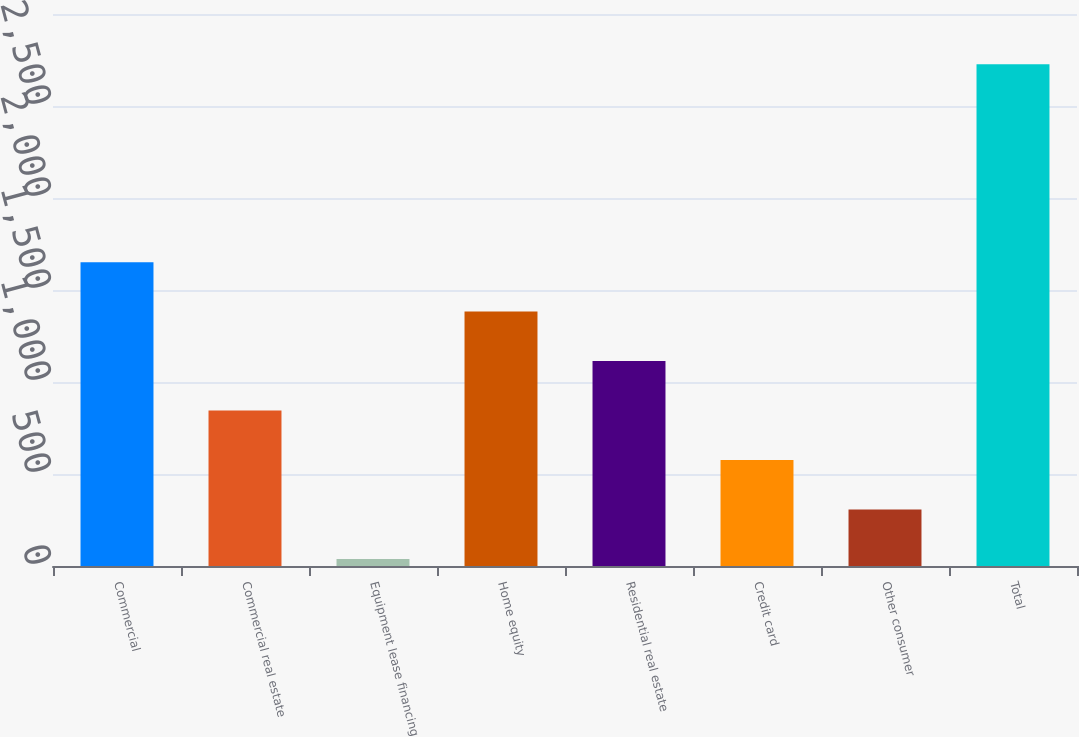Convert chart to OTSL. <chart><loc_0><loc_0><loc_500><loc_500><bar_chart><fcel>Commercial<fcel>Commercial real estate<fcel>Equipment lease financing<fcel>Home equity<fcel>Residential real estate<fcel>Credit card<fcel>Other consumer<fcel>Total<nl><fcel>1651.4<fcel>844.7<fcel>38<fcel>1382.5<fcel>1113.6<fcel>575.8<fcel>306.9<fcel>2727<nl></chart> 